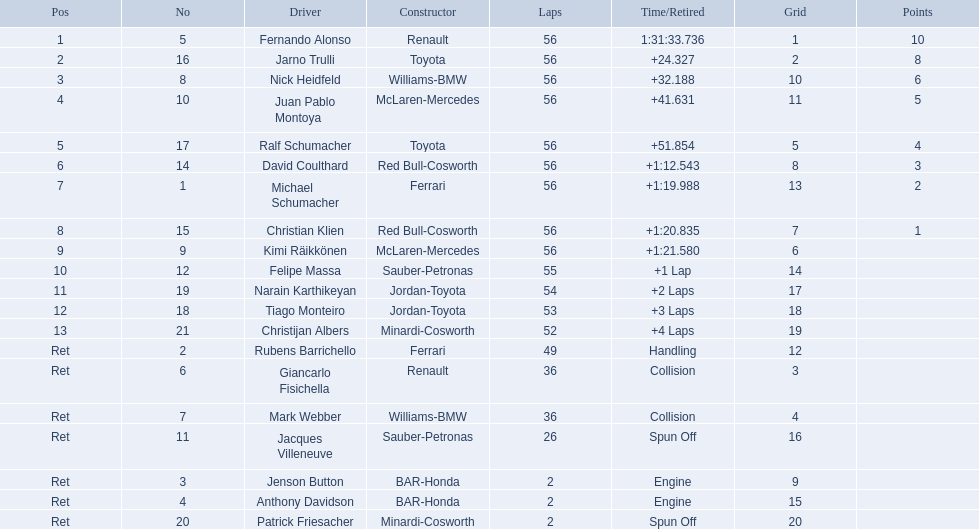Who competed in the 2005 malaysian grand prix? Fernando Alonso, Jarno Trulli, Nick Heidfeld, Juan Pablo Montoya, Ralf Schumacher, David Coulthard, Michael Schumacher, Christian Klien, Kimi Räikkönen, Felipe Massa, Narain Karthikeyan, Tiago Monteiro, Christijan Albers, Rubens Barrichello, Giancarlo Fisichella, Mark Webber, Jacques Villeneuve, Jenson Button, Anthony Davidson, Patrick Friesacher. What were their completion times? 1:31:33.736, +24.327, +32.188, +41.631, +51.854, +1:12.543, +1:19.988, +1:20.835, +1:21.580, +1 Lap, +2 Laps, +3 Laps, +4 Laps, Handling, Collision, Collision, Spun Off, Engine, Engine, Spun Off. What was fernando alonso's completion time? 1:31:33.736. 